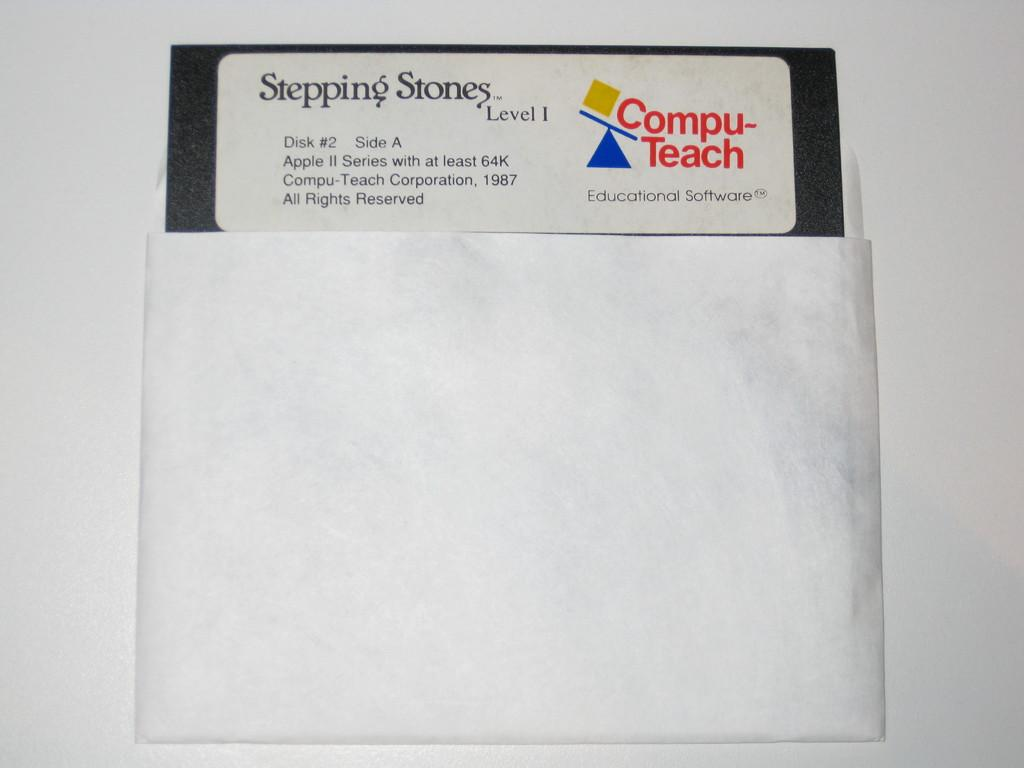<image>
Summarize the visual content of the image. compu teach stepping stones floppy disc used for school 